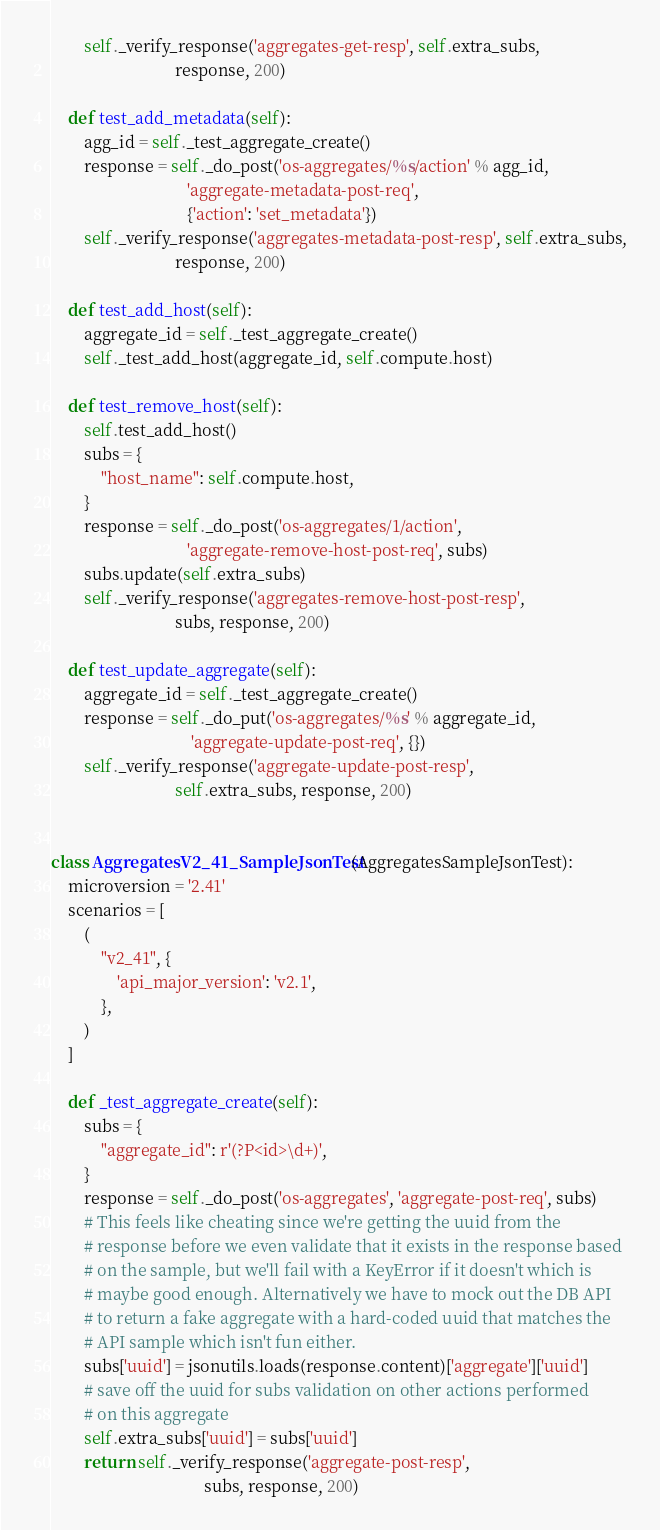<code> <loc_0><loc_0><loc_500><loc_500><_Python_>        self._verify_response('aggregates-get-resp', self.extra_subs,
                              response, 200)

    def test_add_metadata(self):
        agg_id = self._test_aggregate_create()
        response = self._do_post('os-aggregates/%s/action' % agg_id,
                                 'aggregate-metadata-post-req',
                                 {'action': 'set_metadata'})
        self._verify_response('aggregates-metadata-post-resp', self.extra_subs,
                              response, 200)

    def test_add_host(self):
        aggregate_id = self._test_aggregate_create()
        self._test_add_host(aggregate_id, self.compute.host)

    def test_remove_host(self):
        self.test_add_host()
        subs = {
            "host_name": self.compute.host,
        }
        response = self._do_post('os-aggregates/1/action',
                                 'aggregate-remove-host-post-req', subs)
        subs.update(self.extra_subs)
        self._verify_response('aggregates-remove-host-post-resp',
                              subs, response, 200)

    def test_update_aggregate(self):
        aggregate_id = self._test_aggregate_create()
        response = self._do_put('os-aggregates/%s' % aggregate_id,
                                  'aggregate-update-post-req', {})
        self._verify_response('aggregate-update-post-resp',
                              self.extra_subs, response, 200)


class AggregatesV2_41_SampleJsonTest(AggregatesSampleJsonTest):
    microversion = '2.41'
    scenarios = [
        (
            "v2_41", {
                'api_major_version': 'v2.1',
            },
        )
    ]

    def _test_aggregate_create(self):
        subs = {
            "aggregate_id": r'(?P<id>\d+)',
        }
        response = self._do_post('os-aggregates', 'aggregate-post-req', subs)
        # This feels like cheating since we're getting the uuid from the
        # response before we even validate that it exists in the response based
        # on the sample, but we'll fail with a KeyError if it doesn't which is
        # maybe good enough. Alternatively we have to mock out the DB API
        # to return a fake aggregate with a hard-coded uuid that matches the
        # API sample which isn't fun either.
        subs['uuid'] = jsonutils.loads(response.content)['aggregate']['uuid']
        # save off the uuid for subs validation on other actions performed
        # on this aggregate
        self.extra_subs['uuid'] = subs['uuid']
        return self._verify_response('aggregate-post-resp',
                                     subs, response, 200)
</code> 